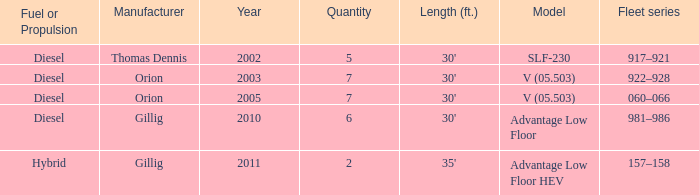Name the sum of quantity for before 2011 model slf-230 5.0. 